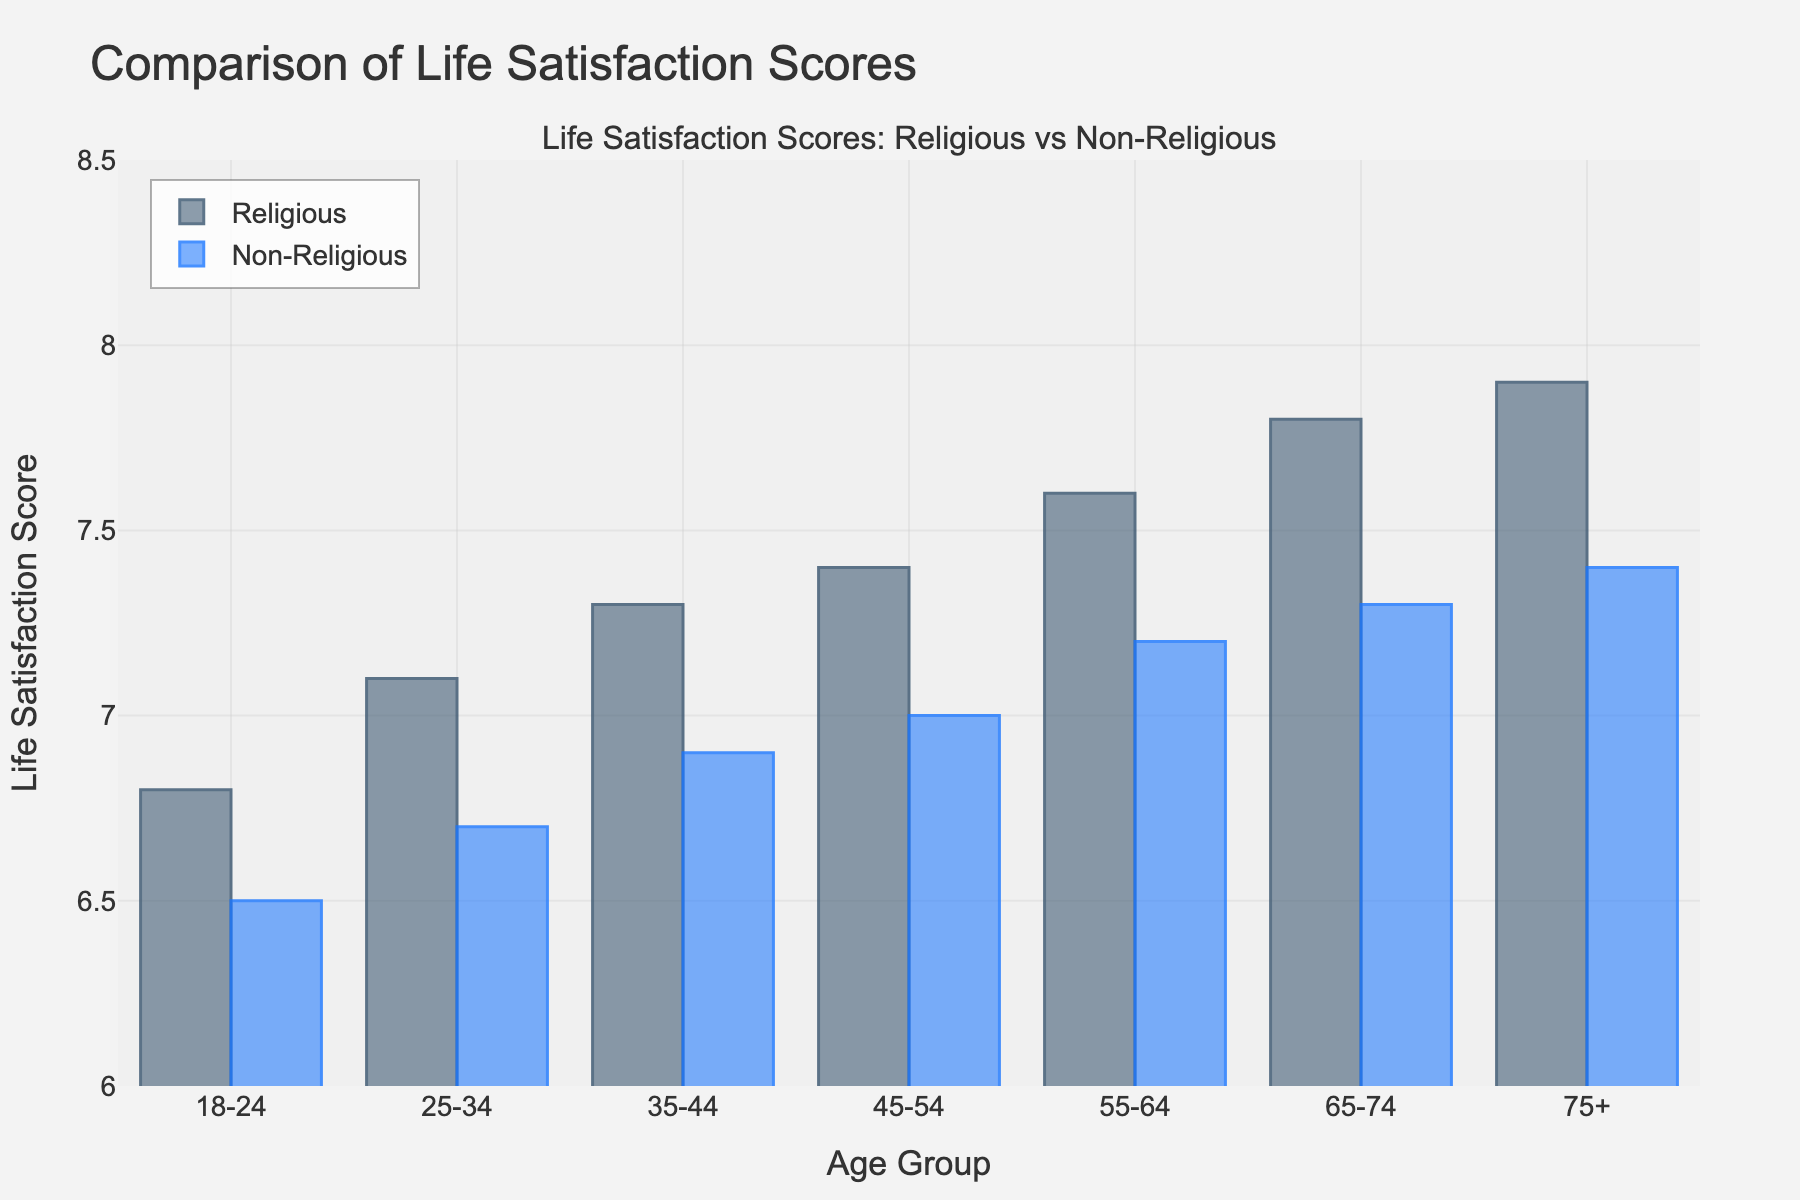Which age group has the highest life satisfaction score among religious individuals? The highest bar for religious individuals corresponds to the 75+ age group, indicating the highest life satisfaction score in this category.
Answer: 75+ Which age group has the smallest gap in life satisfaction scores between religious and non-religious individuals? To find the smallest gap, we calculate the differences for each age group: 18-24 (6.8-6.5), 25-34 (7.1-6.7), 35-44 (7.3-6.9), 45-54 (7.4-7.0), 55-64 (7.6-7.2), 65-74 (7.8-7.3), 75+ (7.9-7.4). The smallest difference is 0.3, which occurs in the 65-74 and 75+ age groups.
Answer: 65-74, 75+ What is the difference in life satisfaction scores between religious and non-religious individuals in the 45-54 age group? The scores for the 45-54 age group are 7.4 (religious) and 7.0 (non-religious). The difference is 7.4 - 7.0.
Answer: 0.4 What is the average life satisfaction score for non-religious individuals across all age groups? To find the average, sum the non-religious scores (6.5 + 6.7 + 6.9 + 7.0 + 7.2 + 7.3 + 7.4) and divide by the number of age groups (7). The sum is 49.0, so the average is 49.0 / 7.
Answer: 7.0 In which age group do religious individuals show the greatest increase in life satisfaction compared to the previous age group? Calculate the increases: 25-34 (7.1 - 6.8), 35-44 (7.3 - 7.1), 45-54 (7.4 - 7.3), 55-64 (7.6 - 7.4), 65-74 (7.8 - 7.6), 75+ (7.9 - 7.8). The greatest increase is 0.2, which occurs in the 55-64 and 65-74 age groups.
Answer: 55-64, 65-74 How does the life satisfaction score trend over different age groups for religious individuals? Observing the bars for religious individuals, the life satisfaction scores increase steadily from the age group 18-24 to 75+.
Answer: Increases steadily Which age group shows the most similar life satisfaction scores between religious and non-religious individuals visually? Visually inspecting the bars, the height difference between the religious and non-religious scores is minimal for the 65-74 age group.
Answer: 65-74 What is the total life satisfaction score for religious individuals in the 18-44 age group? Sum the scores for the 18-24, 25-34, and 35-44 age groups for religious individuals: 6.8 + 7.1 + 7.3. The total is 21.2.
Answer: 21.2 Which group, religious or non-religious, shows a more pronounced increase in life satisfaction scores with age? Comparing the height trends, both groups show an increase with age, but the relative increase is more pronounced for religious individuals as their scores start from 6.8 and reach 7.9.
Answer: Religious What is the difference in life satisfaction scores between the youngest and oldest age groups for non-religious individuals? The scores for the 18-24 and 75+ age groups among non-religious individuals are 6.5 and 7.4, respectively. The difference is 7.4 - 6.5.
Answer: 0.9 